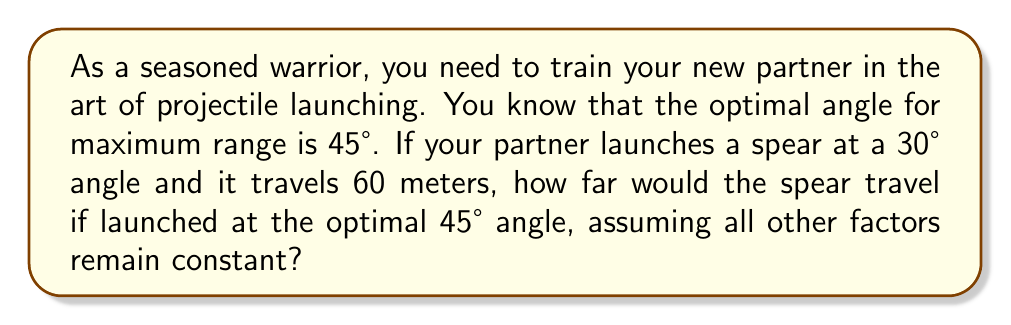Solve this math problem. Let's approach this step-by-step:

1) The range of a projectile is given by the formula:

   $$R = \frac{v^2 \sin(2\theta)}{g}$$

   Where $R$ is the range, $v$ is the initial velocity, $\theta$ is the launch angle, and $g$ is the acceleration due to gravity.

2) We don't know the initial velocity, but we can use the given information to find it. For the 30° launch:

   $$60 = \frac{v^2 \sin(2(30°))}{g}$$

3) Simplify:
   $$60 = \frac{v^2 \sin(60°)}{g} = \frac{v^2 (\sqrt{3}/2)}{g}$$

4) Now, for the 45° launch, the range would be:

   $$R_{45} = \frac{v^2 \sin(2(45°))}{g} = \frac{v^2 \sin(90°)}{g} = \frac{v^2}{g}$$

5) Divide the 45° equation by the 30° equation:

   $$\frac{R_{45}}{60} = \frac{v^2/g}{v^2(\sqrt{3}/2)/g} = \frac{2}{\sqrt{3}} \approx 1.1547$$

6) Therefore:

   $$R_{45} = 60 * \frac{2}{\sqrt{3}} \approx 69.28 \text{ meters}$$
Answer: The spear would travel approximately 69.28 meters when launched at the optimal 45° angle. 